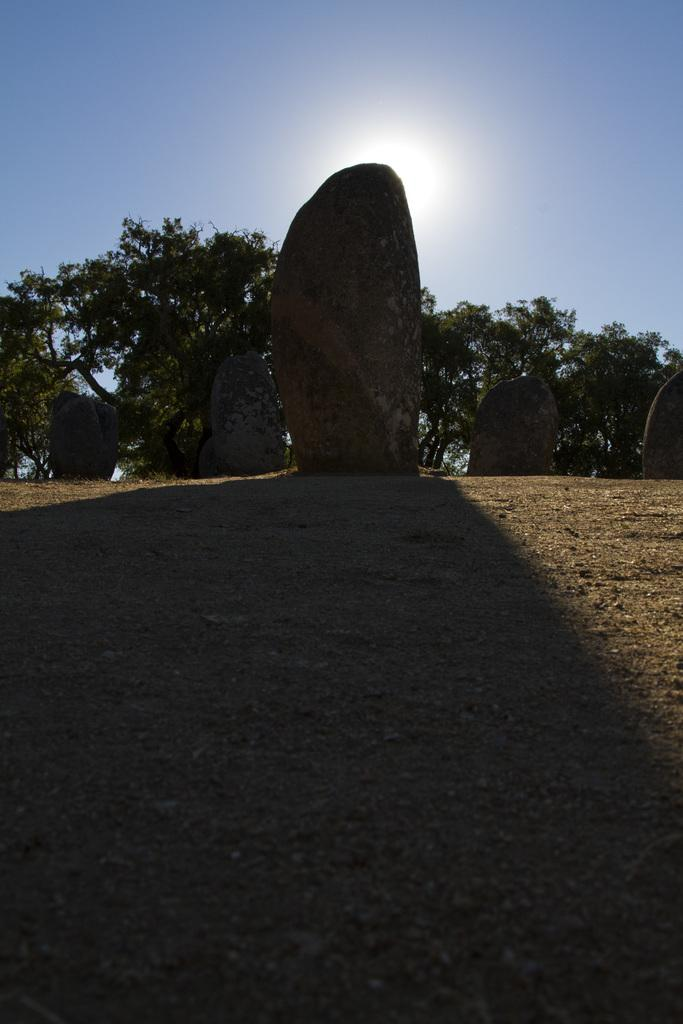What type of structures are present in the image? There are tall stones in the image. How are the stones positioned in the image? The stones are kept on the ground. What can be seen behind the stones in the image? There are trees behind the stones. What is the lighting condition in the image? There is bright sunlight falling on the ground in the image. What type of hat is the snow wearing in the image? There is no snow or hat present in the image. 